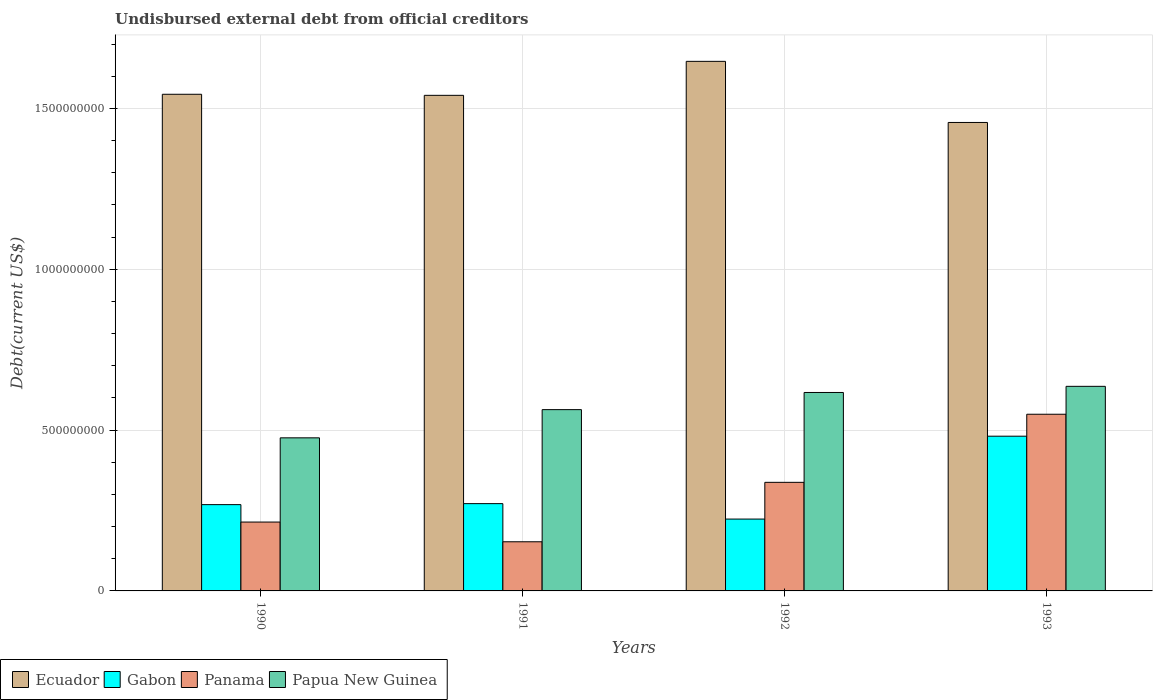Are the number of bars per tick equal to the number of legend labels?
Offer a very short reply. Yes. How many bars are there on the 1st tick from the left?
Offer a very short reply. 4. How many bars are there on the 1st tick from the right?
Offer a terse response. 4. What is the label of the 4th group of bars from the left?
Your answer should be compact. 1993. What is the total debt in Gabon in 1991?
Give a very brief answer. 2.71e+08. Across all years, what is the maximum total debt in Gabon?
Your answer should be compact. 4.81e+08. Across all years, what is the minimum total debt in Papua New Guinea?
Your answer should be compact. 4.76e+08. In which year was the total debt in Papua New Guinea maximum?
Offer a terse response. 1993. What is the total total debt in Panama in the graph?
Provide a succinct answer. 1.25e+09. What is the difference between the total debt in Panama in 1991 and that in 1992?
Keep it short and to the point. -1.85e+08. What is the difference between the total debt in Ecuador in 1992 and the total debt in Papua New Guinea in 1993?
Keep it short and to the point. 1.01e+09. What is the average total debt in Ecuador per year?
Offer a very short reply. 1.55e+09. In the year 1993, what is the difference between the total debt in Papua New Guinea and total debt in Ecuador?
Your response must be concise. -8.20e+08. What is the ratio of the total debt in Gabon in 1992 to that in 1993?
Make the answer very short. 0.46. Is the difference between the total debt in Papua New Guinea in 1990 and 1993 greater than the difference between the total debt in Ecuador in 1990 and 1993?
Provide a succinct answer. No. What is the difference between the highest and the second highest total debt in Ecuador?
Make the answer very short. 1.02e+08. What is the difference between the highest and the lowest total debt in Panama?
Provide a short and direct response. 3.96e+08. Is it the case that in every year, the sum of the total debt in Papua New Guinea and total debt in Ecuador is greater than the sum of total debt in Gabon and total debt in Panama?
Your answer should be compact. No. What does the 3rd bar from the left in 1992 represents?
Offer a terse response. Panama. What does the 1st bar from the right in 1993 represents?
Offer a terse response. Papua New Guinea. Is it the case that in every year, the sum of the total debt in Papua New Guinea and total debt in Ecuador is greater than the total debt in Gabon?
Your answer should be very brief. Yes. How many bars are there?
Offer a very short reply. 16. Are the values on the major ticks of Y-axis written in scientific E-notation?
Your response must be concise. No. How many legend labels are there?
Your answer should be very brief. 4. How are the legend labels stacked?
Offer a very short reply. Horizontal. What is the title of the graph?
Ensure brevity in your answer.  Undisbursed external debt from official creditors. What is the label or title of the X-axis?
Give a very brief answer. Years. What is the label or title of the Y-axis?
Your response must be concise. Debt(current US$). What is the Debt(current US$) of Ecuador in 1990?
Offer a very short reply. 1.54e+09. What is the Debt(current US$) of Gabon in 1990?
Offer a terse response. 2.68e+08. What is the Debt(current US$) in Panama in 1990?
Make the answer very short. 2.14e+08. What is the Debt(current US$) in Papua New Guinea in 1990?
Give a very brief answer. 4.76e+08. What is the Debt(current US$) in Ecuador in 1991?
Your answer should be very brief. 1.54e+09. What is the Debt(current US$) of Gabon in 1991?
Your answer should be compact. 2.71e+08. What is the Debt(current US$) of Panama in 1991?
Your response must be concise. 1.53e+08. What is the Debt(current US$) in Papua New Guinea in 1991?
Offer a terse response. 5.64e+08. What is the Debt(current US$) of Ecuador in 1992?
Your response must be concise. 1.65e+09. What is the Debt(current US$) of Gabon in 1992?
Offer a very short reply. 2.23e+08. What is the Debt(current US$) in Panama in 1992?
Provide a succinct answer. 3.38e+08. What is the Debt(current US$) of Papua New Guinea in 1992?
Offer a terse response. 6.17e+08. What is the Debt(current US$) of Ecuador in 1993?
Keep it short and to the point. 1.46e+09. What is the Debt(current US$) in Gabon in 1993?
Keep it short and to the point. 4.81e+08. What is the Debt(current US$) of Panama in 1993?
Your response must be concise. 5.49e+08. What is the Debt(current US$) of Papua New Guinea in 1993?
Provide a succinct answer. 6.36e+08. Across all years, what is the maximum Debt(current US$) in Ecuador?
Offer a very short reply. 1.65e+09. Across all years, what is the maximum Debt(current US$) of Gabon?
Give a very brief answer. 4.81e+08. Across all years, what is the maximum Debt(current US$) in Panama?
Offer a terse response. 5.49e+08. Across all years, what is the maximum Debt(current US$) in Papua New Guinea?
Provide a succinct answer. 6.36e+08. Across all years, what is the minimum Debt(current US$) of Ecuador?
Keep it short and to the point. 1.46e+09. Across all years, what is the minimum Debt(current US$) of Gabon?
Offer a very short reply. 2.23e+08. Across all years, what is the minimum Debt(current US$) in Panama?
Ensure brevity in your answer.  1.53e+08. Across all years, what is the minimum Debt(current US$) of Papua New Guinea?
Keep it short and to the point. 4.76e+08. What is the total Debt(current US$) of Ecuador in the graph?
Your answer should be very brief. 6.19e+09. What is the total Debt(current US$) of Gabon in the graph?
Your answer should be compact. 1.24e+09. What is the total Debt(current US$) of Panama in the graph?
Ensure brevity in your answer.  1.25e+09. What is the total Debt(current US$) of Papua New Guinea in the graph?
Make the answer very short. 2.29e+09. What is the difference between the Debt(current US$) in Ecuador in 1990 and that in 1991?
Keep it short and to the point. 3.30e+06. What is the difference between the Debt(current US$) of Gabon in 1990 and that in 1991?
Offer a very short reply. -3.11e+06. What is the difference between the Debt(current US$) of Panama in 1990 and that in 1991?
Your answer should be compact. 6.13e+07. What is the difference between the Debt(current US$) in Papua New Guinea in 1990 and that in 1991?
Your response must be concise. -8.77e+07. What is the difference between the Debt(current US$) of Ecuador in 1990 and that in 1992?
Ensure brevity in your answer.  -1.02e+08. What is the difference between the Debt(current US$) in Gabon in 1990 and that in 1992?
Keep it short and to the point. 4.48e+07. What is the difference between the Debt(current US$) of Panama in 1990 and that in 1992?
Your answer should be compact. -1.23e+08. What is the difference between the Debt(current US$) in Papua New Guinea in 1990 and that in 1992?
Provide a short and direct response. -1.41e+08. What is the difference between the Debt(current US$) in Ecuador in 1990 and that in 1993?
Keep it short and to the point. 8.76e+07. What is the difference between the Debt(current US$) in Gabon in 1990 and that in 1993?
Your answer should be very brief. -2.13e+08. What is the difference between the Debt(current US$) of Panama in 1990 and that in 1993?
Your answer should be very brief. -3.35e+08. What is the difference between the Debt(current US$) in Papua New Guinea in 1990 and that in 1993?
Keep it short and to the point. -1.60e+08. What is the difference between the Debt(current US$) of Ecuador in 1991 and that in 1992?
Give a very brief answer. -1.06e+08. What is the difference between the Debt(current US$) in Gabon in 1991 and that in 1992?
Offer a terse response. 4.80e+07. What is the difference between the Debt(current US$) of Panama in 1991 and that in 1992?
Ensure brevity in your answer.  -1.85e+08. What is the difference between the Debt(current US$) of Papua New Guinea in 1991 and that in 1992?
Ensure brevity in your answer.  -5.33e+07. What is the difference between the Debt(current US$) in Ecuador in 1991 and that in 1993?
Give a very brief answer. 8.43e+07. What is the difference between the Debt(current US$) of Gabon in 1991 and that in 1993?
Offer a very short reply. -2.10e+08. What is the difference between the Debt(current US$) of Panama in 1991 and that in 1993?
Your answer should be very brief. -3.96e+08. What is the difference between the Debt(current US$) in Papua New Guinea in 1991 and that in 1993?
Ensure brevity in your answer.  -7.24e+07. What is the difference between the Debt(current US$) of Ecuador in 1992 and that in 1993?
Ensure brevity in your answer.  1.90e+08. What is the difference between the Debt(current US$) of Gabon in 1992 and that in 1993?
Make the answer very short. -2.58e+08. What is the difference between the Debt(current US$) of Panama in 1992 and that in 1993?
Ensure brevity in your answer.  -2.12e+08. What is the difference between the Debt(current US$) of Papua New Guinea in 1992 and that in 1993?
Keep it short and to the point. -1.91e+07. What is the difference between the Debt(current US$) in Ecuador in 1990 and the Debt(current US$) in Gabon in 1991?
Provide a short and direct response. 1.27e+09. What is the difference between the Debt(current US$) of Ecuador in 1990 and the Debt(current US$) of Panama in 1991?
Offer a terse response. 1.39e+09. What is the difference between the Debt(current US$) in Ecuador in 1990 and the Debt(current US$) in Papua New Guinea in 1991?
Ensure brevity in your answer.  9.80e+08. What is the difference between the Debt(current US$) in Gabon in 1990 and the Debt(current US$) in Panama in 1991?
Offer a very short reply. 1.15e+08. What is the difference between the Debt(current US$) of Gabon in 1990 and the Debt(current US$) of Papua New Guinea in 1991?
Your answer should be very brief. -2.95e+08. What is the difference between the Debt(current US$) in Panama in 1990 and the Debt(current US$) in Papua New Guinea in 1991?
Provide a succinct answer. -3.49e+08. What is the difference between the Debt(current US$) of Ecuador in 1990 and the Debt(current US$) of Gabon in 1992?
Your response must be concise. 1.32e+09. What is the difference between the Debt(current US$) in Ecuador in 1990 and the Debt(current US$) in Panama in 1992?
Your answer should be very brief. 1.21e+09. What is the difference between the Debt(current US$) in Ecuador in 1990 and the Debt(current US$) in Papua New Guinea in 1992?
Provide a succinct answer. 9.27e+08. What is the difference between the Debt(current US$) in Gabon in 1990 and the Debt(current US$) in Panama in 1992?
Provide a short and direct response. -6.93e+07. What is the difference between the Debt(current US$) of Gabon in 1990 and the Debt(current US$) of Papua New Guinea in 1992?
Your answer should be compact. -3.49e+08. What is the difference between the Debt(current US$) of Panama in 1990 and the Debt(current US$) of Papua New Guinea in 1992?
Make the answer very short. -4.03e+08. What is the difference between the Debt(current US$) in Ecuador in 1990 and the Debt(current US$) in Gabon in 1993?
Provide a short and direct response. 1.06e+09. What is the difference between the Debt(current US$) of Ecuador in 1990 and the Debt(current US$) of Panama in 1993?
Give a very brief answer. 9.95e+08. What is the difference between the Debt(current US$) in Ecuador in 1990 and the Debt(current US$) in Papua New Guinea in 1993?
Give a very brief answer. 9.08e+08. What is the difference between the Debt(current US$) in Gabon in 1990 and the Debt(current US$) in Panama in 1993?
Provide a short and direct response. -2.81e+08. What is the difference between the Debt(current US$) in Gabon in 1990 and the Debt(current US$) in Papua New Guinea in 1993?
Provide a short and direct response. -3.68e+08. What is the difference between the Debt(current US$) in Panama in 1990 and the Debt(current US$) in Papua New Guinea in 1993?
Make the answer very short. -4.22e+08. What is the difference between the Debt(current US$) in Ecuador in 1991 and the Debt(current US$) in Gabon in 1992?
Offer a very short reply. 1.32e+09. What is the difference between the Debt(current US$) in Ecuador in 1991 and the Debt(current US$) in Panama in 1992?
Your response must be concise. 1.20e+09. What is the difference between the Debt(current US$) of Ecuador in 1991 and the Debt(current US$) of Papua New Guinea in 1992?
Your answer should be very brief. 9.24e+08. What is the difference between the Debt(current US$) of Gabon in 1991 and the Debt(current US$) of Panama in 1992?
Ensure brevity in your answer.  -6.62e+07. What is the difference between the Debt(current US$) of Gabon in 1991 and the Debt(current US$) of Papua New Guinea in 1992?
Your answer should be very brief. -3.46e+08. What is the difference between the Debt(current US$) in Panama in 1991 and the Debt(current US$) in Papua New Guinea in 1992?
Give a very brief answer. -4.64e+08. What is the difference between the Debt(current US$) in Ecuador in 1991 and the Debt(current US$) in Gabon in 1993?
Offer a terse response. 1.06e+09. What is the difference between the Debt(current US$) in Ecuador in 1991 and the Debt(current US$) in Panama in 1993?
Provide a succinct answer. 9.91e+08. What is the difference between the Debt(current US$) in Ecuador in 1991 and the Debt(current US$) in Papua New Guinea in 1993?
Offer a terse response. 9.05e+08. What is the difference between the Debt(current US$) in Gabon in 1991 and the Debt(current US$) in Panama in 1993?
Give a very brief answer. -2.78e+08. What is the difference between the Debt(current US$) of Gabon in 1991 and the Debt(current US$) of Papua New Guinea in 1993?
Offer a very short reply. -3.65e+08. What is the difference between the Debt(current US$) in Panama in 1991 and the Debt(current US$) in Papua New Guinea in 1993?
Provide a succinct answer. -4.83e+08. What is the difference between the Debt(current US$) of Ecuador in 1992 and the Debt(current US$) of Gabon in 1993?
Your response must be concise. 1.17e+09. What is the difference between the Debt(current US$) of Ecuador in 1992 and the Debt(current US$) of Panama in 1993?
Offer a terse response. 1.10e+09. What is the difference between the Debt(current US$) in Ecuador in 1992 and the Debt(current US$) in Papua New Guinea in 1993?
Provide a succinct answer. 1.01e+09. What is the difference between the Debt(current US$) in Gabon in 1992 and the Debt(current US$) in Panama in 1993?
Provide a succinct answer. -3.26e+08. What is the difference between the Debt(current US$) of Gabon in 1992 and the Debt(current US$) of Papua New Guinea in 1993?
Offer a terse response. -4.13e+08. What is the difference between the Debt(current US$) of Panama in 1992 and the Debt(current US$) of Papua New Guinea in 1993?
Make the answer very short. -2.98e+08. What is the average Debt(current US$) in Ecuador per year?
Provide a short and direct response. 1.55e+09. What is the average Debt(current US$) in Gabon per year?
Keep it short and to the point. 3.11e+08. What is the average Debt(current US$) in Panama per year?
Offer a very short reply. 3.13e+08. What is the average Debt(current US$) of Papua New Guinea per year?
Give a very brief answer. 5.73e+08. In the year 1990, what is the difference between the Debt(current US$) in Ecuador and Debt(current US$) in Gabon?
Make the answer very short. 1.28e+09. In the year 1990, what is the difference between the Debt(current US$) in Ecuador and Debt(current US$) in Panama?
Your response must be concise. 1.33e+09. In the year 1990, what is the difference between the Debt(current US$) of Ecuador and Debt(current US$) of Papua New Guinea?
Your answer should be very brief. 1.07e+09. In the year 1990, what is the difference between the Debt(current US$) of Gabon and Debt(current US$) of Panama?
Offer a terse response. 5.41e+07. In the year 1990, what is the difference between the Debt(current US$) in Gabon and Debt(current US$) in Papua New Guinea?
Your answer should be compact. -2.08e+08. In the year 1990, what is the difference between the Debt(current US$) of Panama and Debt(current US$) of Papua New Guinea?
Your answer should be very brief. -2.62e+08. In the year 1991, what is the difference between the Debt(current US$) of Ecuador and Debt(current US$) of Gabon?
Give a very brief answer. 1.27e+09. In the year 1991, what is the difference between the Debt(current US$) in Ecuador and Debt(current US$) in Panama?
Provide a succinct answer. 1.39e+09. In the year 1991, what is the difference between the Debt(current US$) of Ecuador and Debt(current US$) of Papua New Guinea?
Provide a short and direct response. 9.77e+08. In the year 1991, what is the difference between the Debt(current US$) of Gabon and Debt(current US$) of Panama?
Your answer should be very brief. 1.19e+08. In the year 1991, what is the difference between the Debt(current US$) of Gabon and Debt(current US$) of Papua New Guinea?
Your response must be concise. -2.92e+08. In the year 1991, what is the difference between the Debt(current US$) of Panama and Debt(current US$) of Papua New Guinea?
Ensure brevity in your answer.  -4.11e+08. In the year 1992, what is the difference between the Debt(current US$) in Ecuador and Debt(current US$) in Gabon?
Offer a terse response. 1.42e+09. In the year 1992, what is the difference between the Debt(current US$) in Ecuador and Debt(current US$) in Panama?
Your answer should be compact. 1.31e+09. In the year 1992, what is the difference between the Debt(current US$) in Ecuador and Debt(current US$) in Papua New Guinea?
Provide a short and direct response. 1.03e+09. In the year 1992, what is the difference between the Debt(current US$) in Gabon and Debt(current US$) in Panama?
Your answer should be compact. -1.14e+08. In the year 1992, what is the difference between the Debt(current US$) of Gabon and Debt(current US$) of Papua New Guinea?
Keep it short and to the point. -3.93e+08. In the year 1992, what is the difference between the Debt(current US$) of Panama and Debt(current US$) of Papua New Guinea?
Give a very brief answer. -2.79e+08. In the year 1993, what is the difference between the Debt(current US$) in Ecuador and Debt(current US$) in Gabon?
Provide a succinct answer. 9.75e+08. In the year 1993, what is the difference between the Debt(current US$) in Ecuador and Debt(current US$) in Panama?
Make the answer very short. 9.07e+08. In the year 1993, what is the difference between the Debt(current US$) in Ecuador and Debt(current US$) in Papua New Guinea?
Your answer should be very brief. 8.20e+08. In the year 1993, what is the difference between the Debt(current US$) of Gabon and Debt(current US$) of Panama?
Keep it short and to the point. -6.82e+07. In the year 1993, what is the difference between the Debt(current US$) of Gabon and Debt(current US$) of Papua New Guinea?
Your answer should be compact. -1.55e+08. In the year 1993, what is the difference between the Debt(current US$) in Panama and Debt(current US$) in Papua New Guinea?
Your answer should be compact. -8.67e+07. What is the ratio of the Debt(current US$) in Panama in 1990 to that in 1991?
Your answer should be compact. 1.4. What is the ratio of the Debt(current US$) in Papua New Guinea in 1990 to that in 1991?
Your answer should be compact. 0.84. What is the ratio of the Debt(current US$) in Ecuador in 1990 to that in 1992?
Make the answer very short. 0.94. What is the ratio of the Debt(current US$) of Gabon in 1990 to that in 1992?
Give a very brief answer. 1.2. What is the ratio of the Debt(current US$) in Panama in 1990 to that in 1992?
Your answer should be very brief. 0.63. What is the ratio of the Debt(current US$) in Papua New Guinea in 1990 to that in 1992?
Your response must be concise. 0.77. What is the ratio of the Debt(current US$) in Ecuador in 1990 to that in 1993?
Make the answer very short. 1.06. What is the ratio of the Debt(current US$) in Gabon in 1990 to that in 1993?
Your response must be concise. 0.56. What is the ratio of the Debt(current US$) of Panama in 1990 to that in 1993?
Offer a terse response. 0.39. What is the ratio of the Debt(current US$) in Papua New Guinea in 1990 to that in 1993?
Give a very brief answer. 0.75. What is the ratio of the Debt(current US$) in Ecuador in 1991 to that in 1992?
Your answer should be very brief. 0.94. What is the ratio of the Debt(current US$) in Gabon in 1991 to that in 1992?
Provide a succinct answer. 1.21. What is the ratio of the Debt(current US$) in Panama in 1991 to that in 1992?
Make the answer very short. 0.45. What is the ratio of the Debt(current US$) of Papua New Guinea in 1991 to that in 1992?
Provide a short and direct response. 0.91. What is the ratio of the Debt(current US$) of Ecuador in 1991 to that in 1993?
Give a very brief answer. 1.06. What is the ratio of the Debt(current US$) of Gabon in 1991 to that in 1993?
Your answer should be compact. 0.56. What is the ratio of the Debt(current US$) in Panama in 1991 to that in 1993?
Ensure brevity in your answer.  0.28. What is the ratio of the Debt(current US$) of Papua New Guinea in 1991 to that in 1993?
Make the answer very short. 0.89. What is the ratio of the Debt(current US$) in Ecuador in 1992 to that in 1993?
Give a very brief answer. 1.13. What is the ratio of the Debt(current US$) of Gabon in 1992 to that in 1993?
Your response must be concise. 0.46. What is the ratio of the Debt(current US$) in Panama in 1992 to that in 1993?
Your answer should be very brief. 0.61. What is the difference between the highest and the second highest Debt(current US$) of Ecuador?
Keep it short and to the point. 1.02e+08. What is the difference between the highest and the second highest Debt(current US$) of Gabon?
Your answer should be compact. 2.10e+08. What is the difference between the highest and the second highest Debt(current US$) of Panama?
Make the answer very short. 2.12e+08. What is the difference between the highest and the second highest Debt(current US$) in Papua New Guinea?
Ensure brevity in your answer.  1.91e+07. What is the difference between the highest and the lowest Debt(current US$) in Ecuador?
Make the answer very short. 1.90e+08. What is the difference between the highest and the lowest Debt(current US$) of Gabon?
Keep it short and to the point. 2.58e+08. What is the difference between the highest and the lowest Debt(current US$) of Panama?
Offer a very short reply. 3.96e+08. What is the difference between the highest and the lowest Debt(current US$) in Papua New Guinea?
Your answer should be compact. 1.60e+08. 